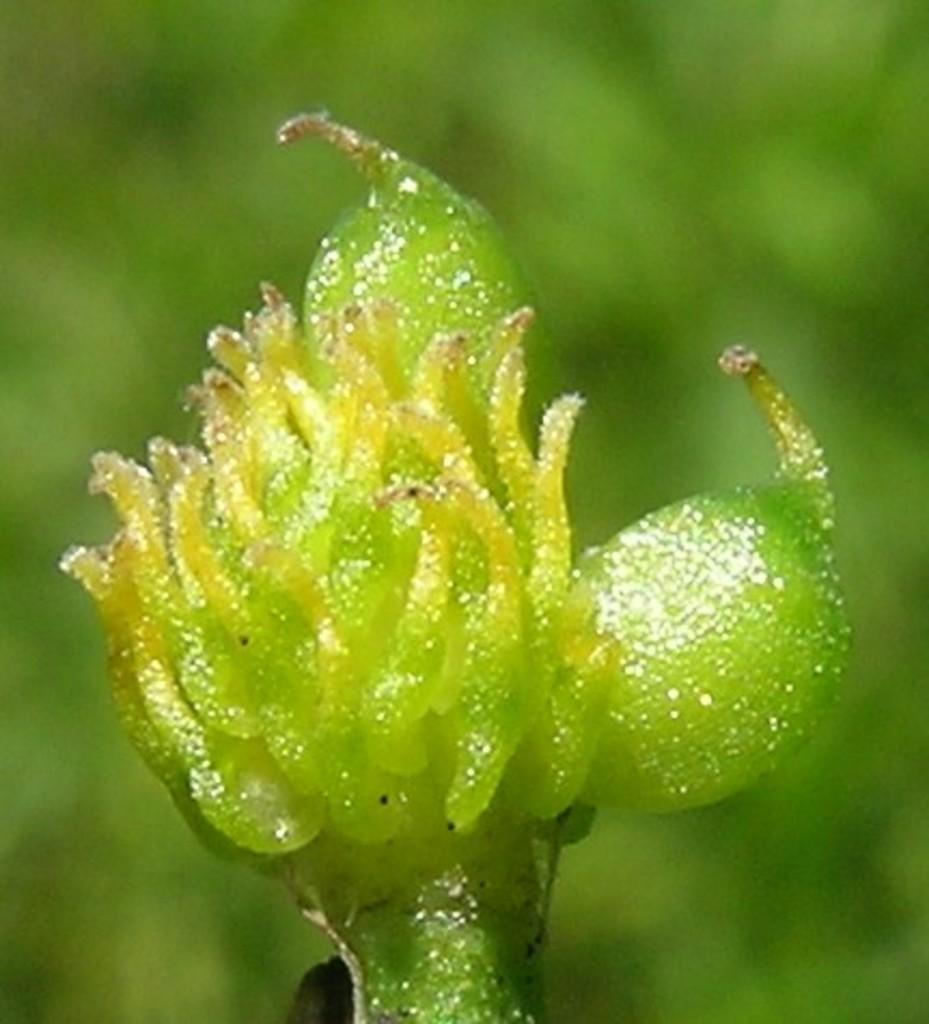What can be seen in the image? There is an object in the image. What is the color of the object? The object is green in color. Is there any blood visible on the object in the image? No, there is no blood visible on the object in the image. 